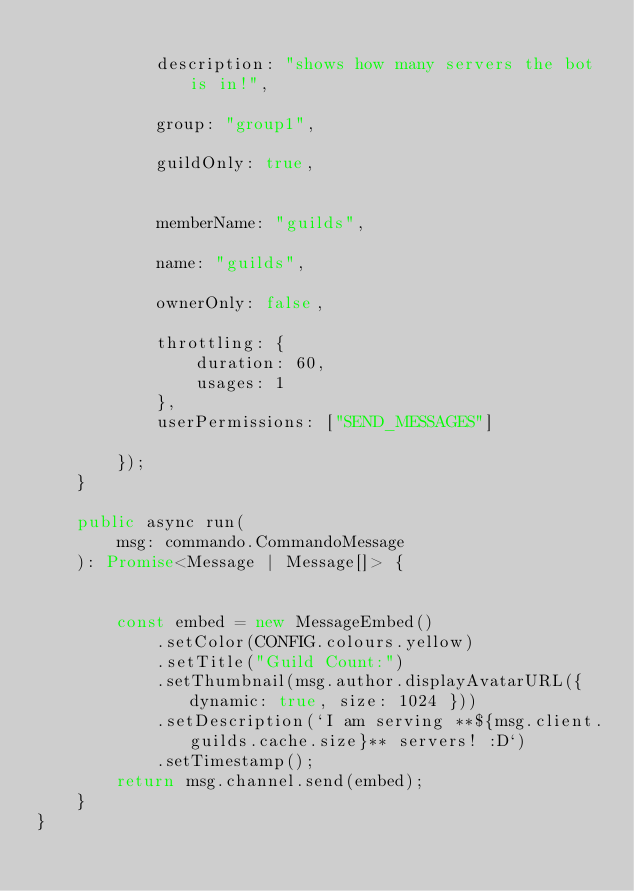Convert code to text. <code><loc_0><loc_0><loc_500><loc_500><_TypeScript_>
            description: "shows how many servers the bot is in!",

            group: "group1",

            guildOnly: true,


            memberName: "guilds",

            name: "guilds",

            ownerOnly: false,

            throttling: {
                duration: 60,
                usages: 1
            },
            userPermissions: ["SEND_MESSAGES"]

        });
    }

    public async run(
        msg: commando.CommandoMessage
    ): Promise<Message | Message[]> {


        const embed = new MessageEmbed()
            .setColor(CONFIG.colours.yellow)
            .setTitle("Guild Count:")
            .setThumbnail(msg.author.displayAvatarURL({ dynamic: true, size: 1024 }))
            .setDescription(`I am serving **${msg.client.guilds.cache.size}** servers! :D`)
            .setTimestamp();
        return msg.channel.send(embed);
    }
}</code> 